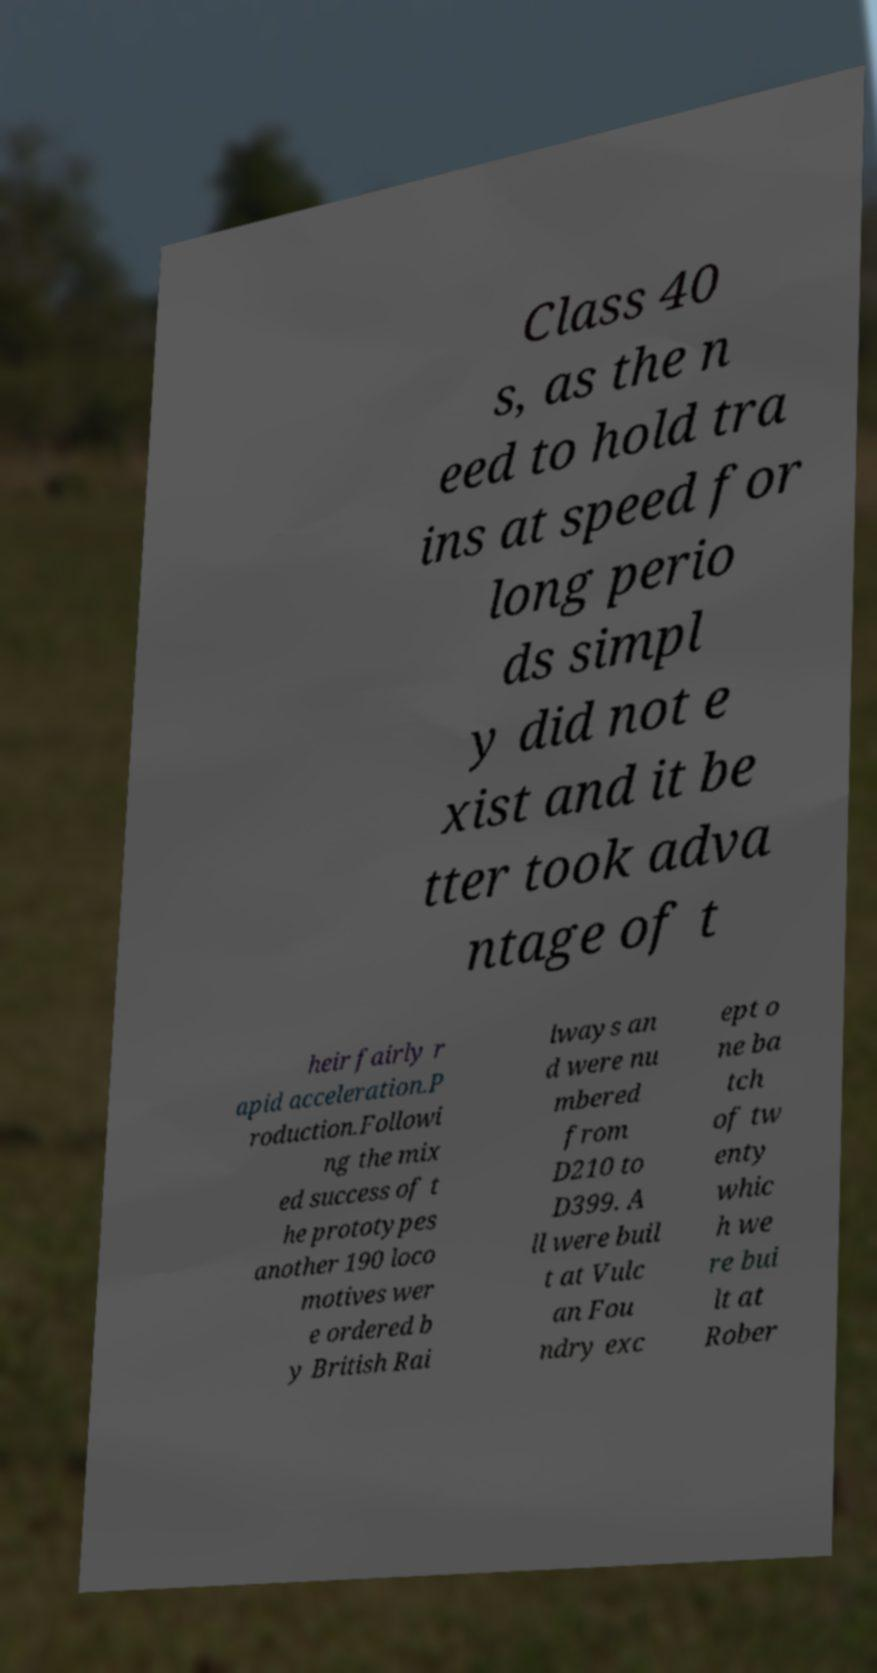For documentation purposes, I need the text within this image transcribed. Could you provide that? Class 40 s, as the n eed to hold tra ins at speed for long perio ds simpl y did not e xist and it be tter took adva ntage of t heir fairly r apid acceleration.P roduction.Followi ng the mix ed success of t he prototypes another 190 loco motives wer e ordered b y British Rai lways an d were nu mbered from D210 to D399. A ll were buil t at Vulc an Fou ndry exc ept o ne ba tch of tw enty whic h we re bui lt at Rober 